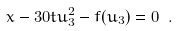<formula> <loc_0><loc_0><loc_500><loc_500>x - 3 0 t u _ { 3 } ^ { 2 } - f ( u _ { 3 } ) = 0 \ .</formula> 